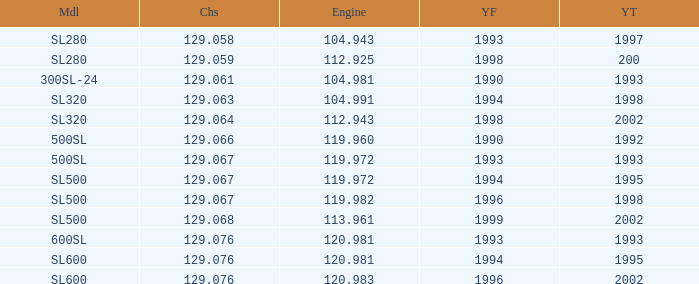Which Engine has a Model of sl500, and a Year From larger than 1999? None. 